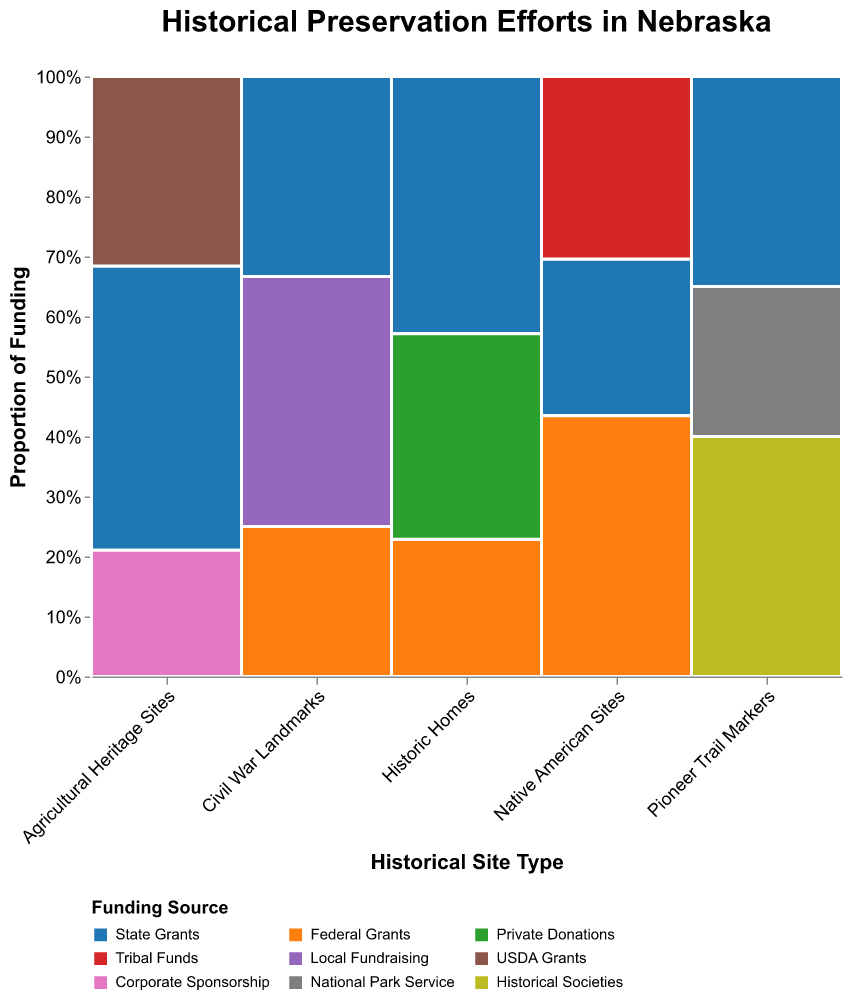What are the different site types represented in the plot? The plot has an axis labeled "Historical Site Type," which includes categories for the different site types. These site types can be identified by reading the distinct categories along this axis.
Answer: Historic Homes, Native American Sites, Civil War Landmarks, Agricultural Heritage Sites, Pioneer Trail Markers Which funding source is most frequently used for Historic Homes? By examining the segment for Historic Homes and observing the largest block within it, which is represented by a corresponding color in the legend, it becomes clear that State Grants have the highest proportion of funding.
Answer: State Grants How many total funding sources are used for Native American Sites? By looking at the different colored segments within the Native American Sites section of the plot, it is possible to count the number of distinct blocks, each representing a different funding source.
Answer: 3 What proportion of funding for Civil War Landmarks comes from Local Fundraising? Examine the section of the plot for Civil War Landmarks and determine the height of the Local Fundraising segment. The y-axis represents the proportion of funding, making it easy to estimate this proportion.
Answer: Approximately 33.3% Which historical site type receives the least amount of State Grants? By identifying the smallest segment corresponding to State Grants within each site type and comparing their sizes, it becomes clear that Civil War Landmarks receive the least amount of State Grants compared to the other site types.
Answer: Civil War Landmarks Compare the Federal Grants for Historic Homes and Native American Sites; which one receives more? Look at the segments for Federal Grants in both Historic Homes and Native American Sites. By comparing the heights of these segments, it is evident which one is larger.
Answer: Native American Sites What proportion of funding for Agricultural Heritage Sites comes from USDA Grants and Corporate Sponsorship combined? Identify and measure the segments for USDA Grants and Corporate Sponsorship under Agricultural Heritage Sites. Add these proportions together to find the combined proportion.
Answer: Approximately 55.6% What is the total count of all funding sources combined for Pioneer Trail Markers? Use the tooltip feature by hovering over each segment in the Pioneer Trail Markers section to get the count of each funding source, then sum up these counts.
Answer: 20 How does the proportion of Federal Grants compare between Historic Homes and Civil War Landmarks? Examine the segments for Federal Grants in both Historic Homes and Civil War Landmarks. Compare their heights to see which is proportionally larger relative to the total funding for each site type.
Answer: Higher for Historic Homes Which historical site type relies most heavily on Private Donations? Look for the Private Donations segment's height across all site types to identify which one has the largest proportion, indicating heavy reliance on this funding source.
Answer: Historic Homes 